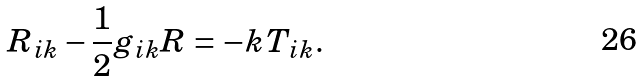<formula> <loc_0><loc_0><loc_500><loc_500>R _ { i k } - { \frac { 1 } { 2 } } g _ { i k } R = - k T _ { i k } .</formula> 